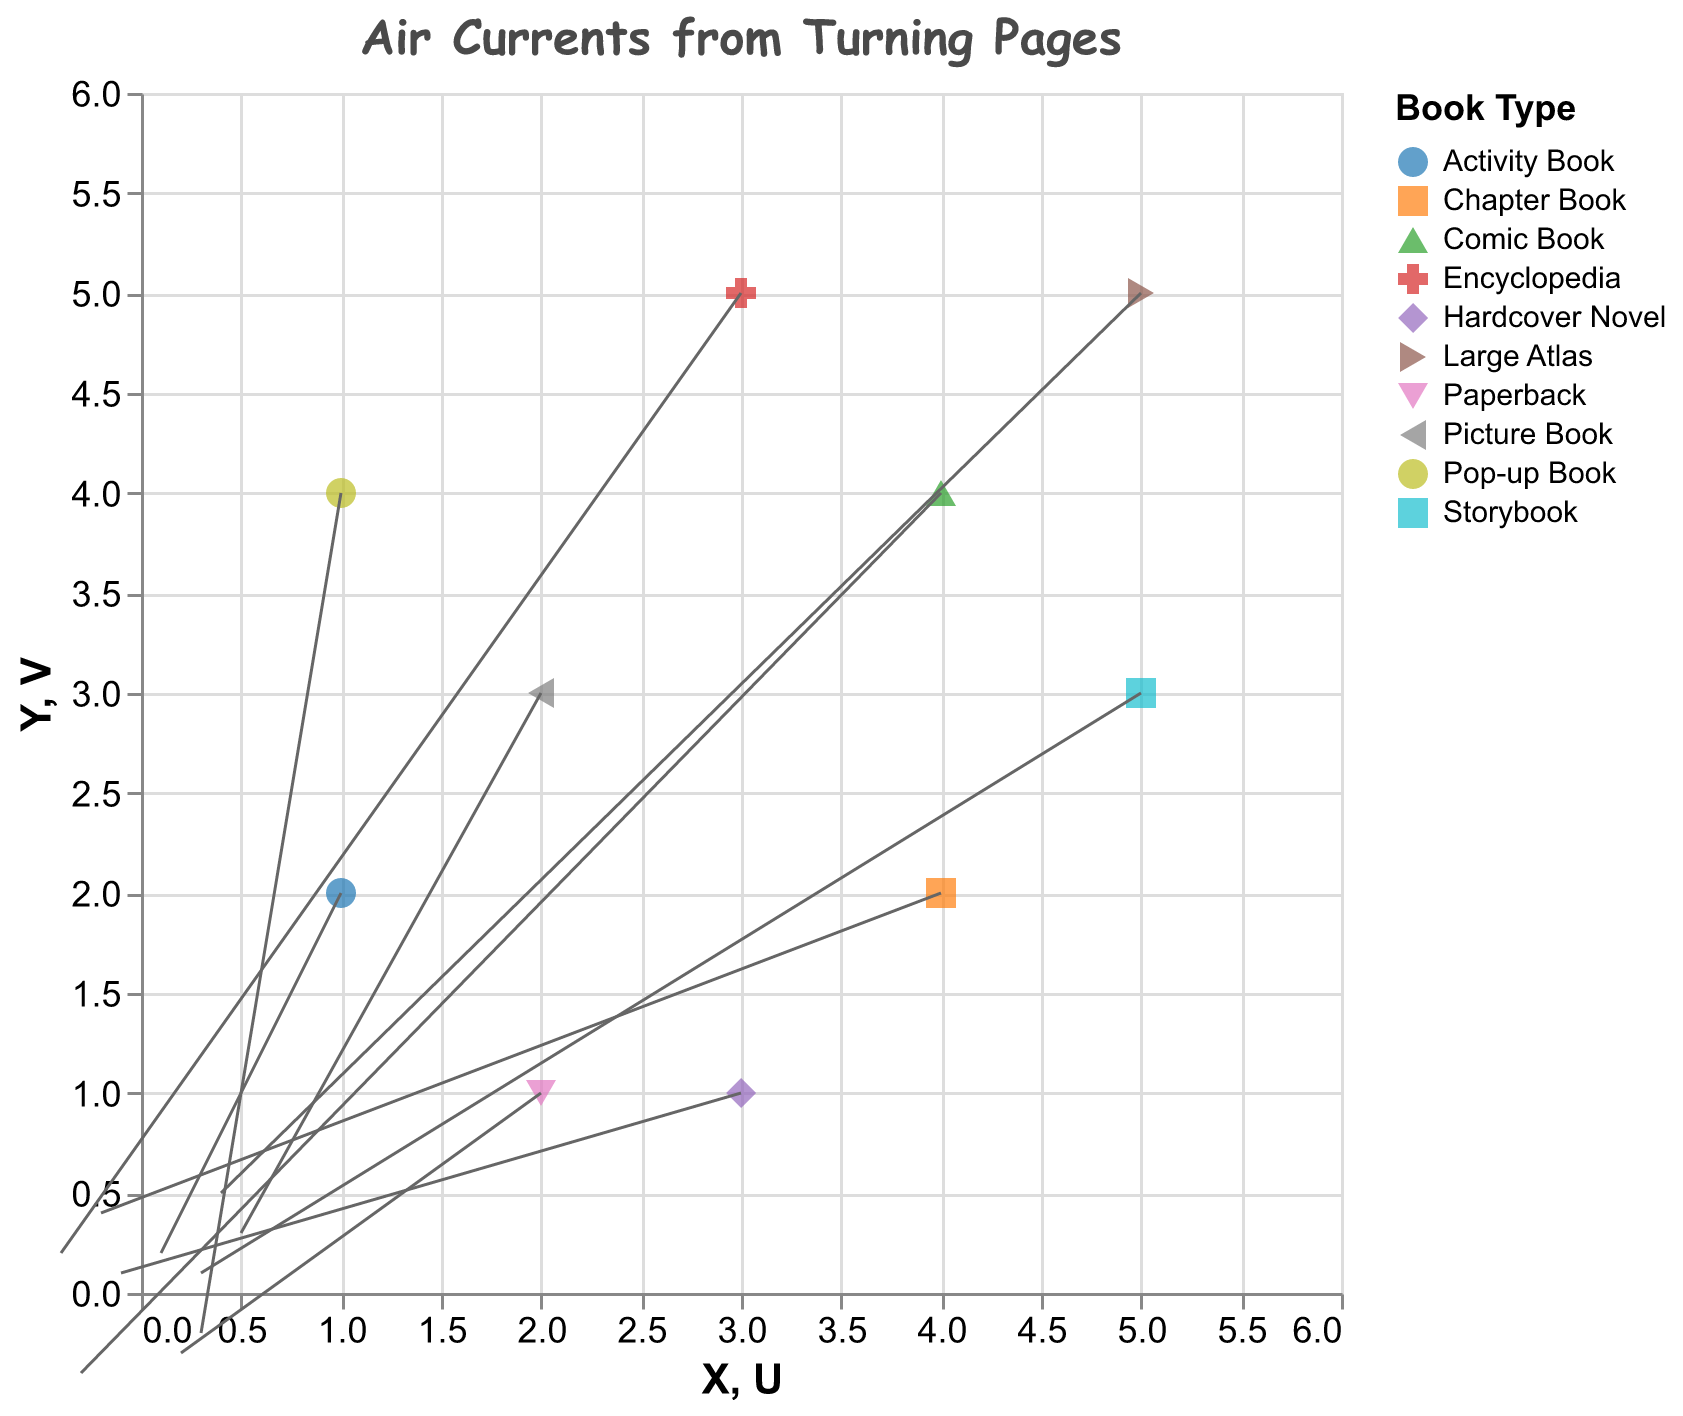How many book types are represented in the plot? We can count the distinct colors/shapes in the legend, each representing a different book type.
Answer: 10 What is the direction of the air current for the Picture Book? Find the point labeled "Picture Book" and observe the direction of the arrow starting from that point.
Answer: Right and slightly up Which book type has the largest upward air current? Compare the lengths and directions of the arrows pointing upwards for each book type.
Answer: Large Atlas Are there any book types with air currents pointing exactly to the left? Look for arrows where the X component of the arrow is negative and the Y component is zero.
Answer: No Which book type has the smallest air current magnitude? Calculate the magnitude of each vector (U, V) as sqrt(U^2 + V^2) and find the smallest value.
Answer: Hardcover Novel What are the X and Y coordinates of the Large Atlas? Locate the arrow labeled "Large Atlas" and note its starting X and Y coordinates.
Answer: (5, 5) For which book type is the air current moving down and to the left? Identify arrows with both negative U and V components.
Answer: Comic Book How do the air currents of the Picture Book and Pop-up Book compare in magnitude? Calculate the magnitudes of both vectors and compare them. Picture Book: sqrt(0.5^2 + 0.3^2) = 0.583, Pop-up Book: sqrt(0.3^2 + (-0.2)^2) = 0.36
Answer: Picture Book has a larger air current magnitude Which book type has an air current pointing downwards but not horizontally? Identify the arrows where the V component is negative and U component is zero or close to zero.
Answer: Paperback What is the average horizontal (U) component of all air currents? Sum all the U components and divide by the number of data points: (0.5 - 0.2 + 0.3 - 0.1 + 0.4 + 0.2 - 0.3 + 0.1 - 0.4 + 0.3) / 10 = 0.08
Answer: 0.08 